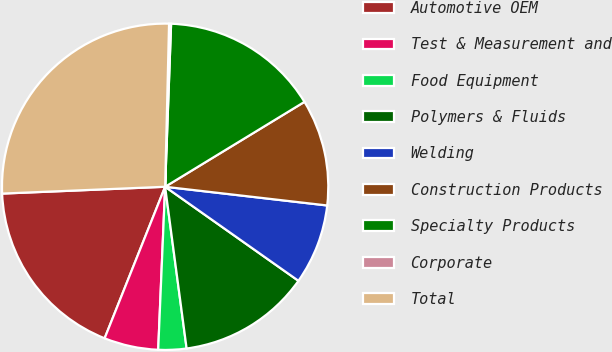<chart> <loc_0><loc_0><loc_500><loc_500><pie_chart><fcel>Automotive OEM<fcel>Test & Measurement and<fcel>Food Equipment<fcel>Polymers & Fluids<fcel>Welding<fcel>Construction Products<fcel>Specialty Products<fcel>Corporate<fcel>Total<nl><fcel>18.29%<fcel>5.37%<fcel>2.78%<fcel>13.12%<fcel>7.95%<fcel>10.54%<fcel>15.71%<fcel>0.2%<fcel>26.05%<nl></chart> 